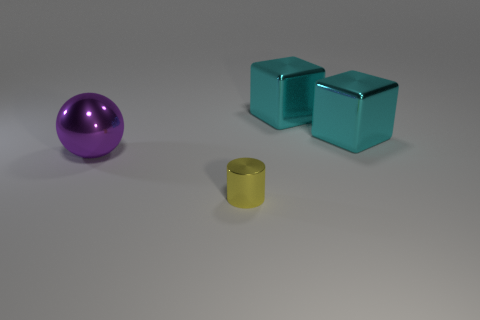Add 3 tiny yellow metallic cylinders. How many objects exist? 7 Subtract all spheres. How many objects are left? 3 Subtract 1 cubes. How many cubes are left? 1 Add 2 cyan blocks. How many cyan blocks exist? 4 Subtract 0 yellow spheres. How many objects are left? 4 Subtract all green cylinders. Subtract all blue cubes. How many cylinders are left? 1 Subtract all large spheres. Subtract all small cyan shiny spheres. How many objects are left? 3 Add 3 large cyan shiny objects. How many large cyan shiny objects are left? 5 